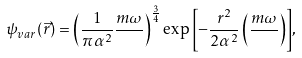Convert formula to latex. <formula><loc_0><loc_0><loc_500><loc_500>\psi _ { v a r } ( \vec { r } ) = \left ( \frac { 1 } { \pi \alpha ^ { 2 } } \frac { m \omega } { } \right ) ^ { \frac { 3 } { 4 } } \exp { \left [ - \frac { r ^ { 2 } } { 2 \alpha ^ { 2 } } \left ( \frac { m \omega } { } \right ) \right ] } ,</formula> 